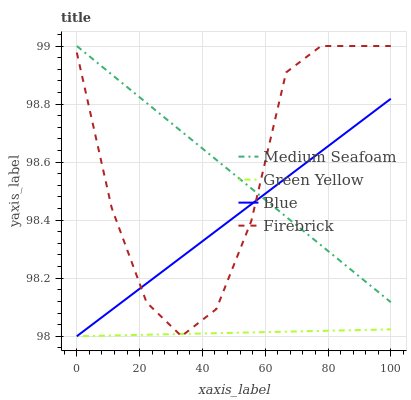Does Green Yellow have the minimum area under the curve?
Answer yes or no. Yes. Does Medium Seafoam have the maximum area under the curve?
Answer yes or no. Yes. Does Firebrick have the minimum area under the curve?
Answer yes or no. No. Does Firebrick have the maximum area under the curve?
Answer yes or no. No. Is Medium Seafoam the smoothest?
Answer yes or no. Yes. Is Firebrick the roughest?
Answer yes or no. Yes. Is Green Yellow the smoothest?
Answer yes or no. No. Is Green Yellow the roughest?
Answer yes or no. No. Does Blue have the lowest value?
Answer yes or no. Yes. Does Firebrick have the lowest value?
Answer yes or no. No. Does Medium Seafoam have the highest value?
Answer yes or no. Yes. Does Green Yellow have the highest value?
Answer yes or no. No. Is Green Yellow less than Medium Seafoam?
Answer yes or no. Yes. Is Medium Seafoam greater than Green Yellow?
Answer yes or no. Yes. Does Medium Seafoam intersect Blue?
Answer yes or no. Yes. Is Medium Seafoam less than Blue?
Answer yes or no. No. Is Medium Seafoam greater than Blue?
Answer yes or no. No. Does Green Yellow intersect Medium Seafoam?
Answer yes or no. No. 